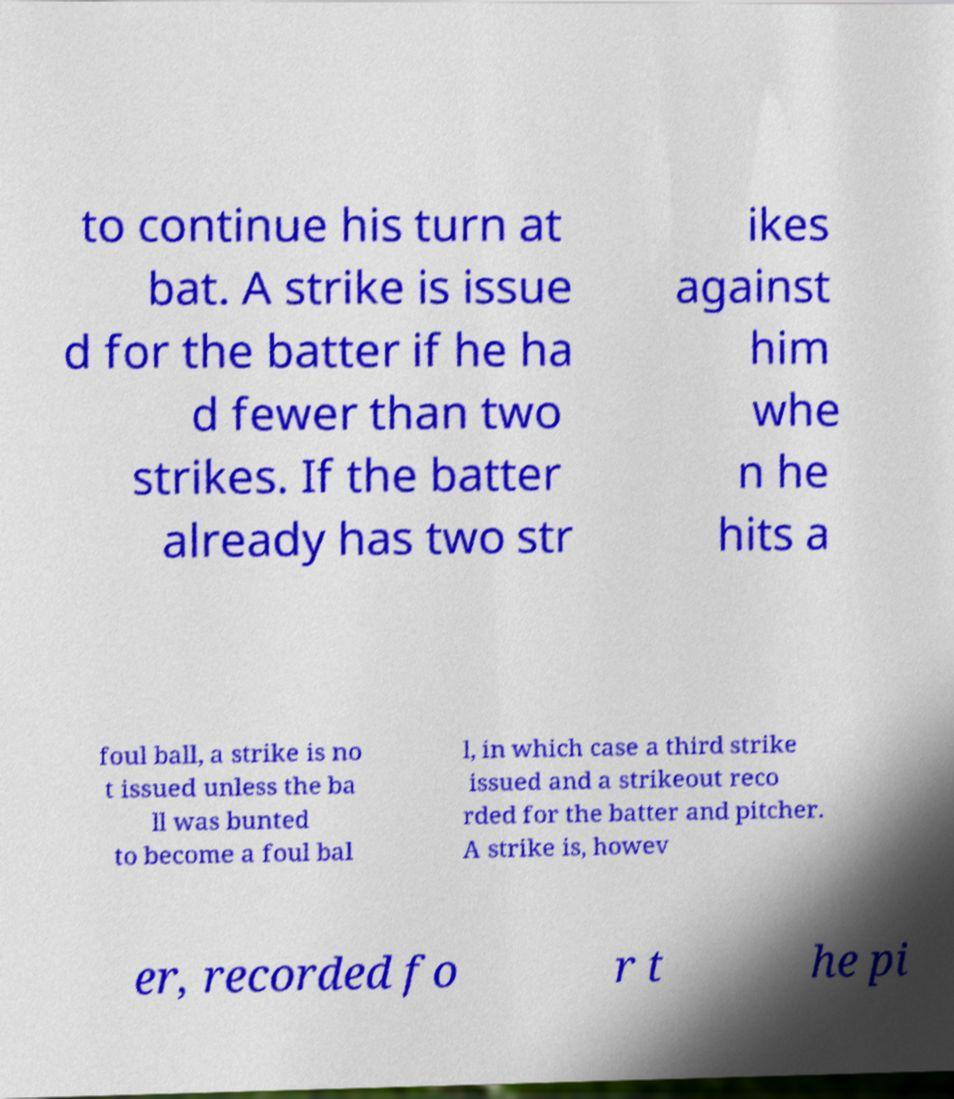What messages or text are displayed in this image? I need them in a readable, typed format. to continue his turn at bat. A strike is issue d for the batter if he ha d fewer than two strikes. If the batter already has two str ikes against him whe n he hits a foul ball, a strike is no t issued unless the ba ll was bunted to become a foul bal l, in which case a third strike issued and a strikeout reco rded for the batter and pitcher. A strike is, howev er, recorded fo r t he pi 